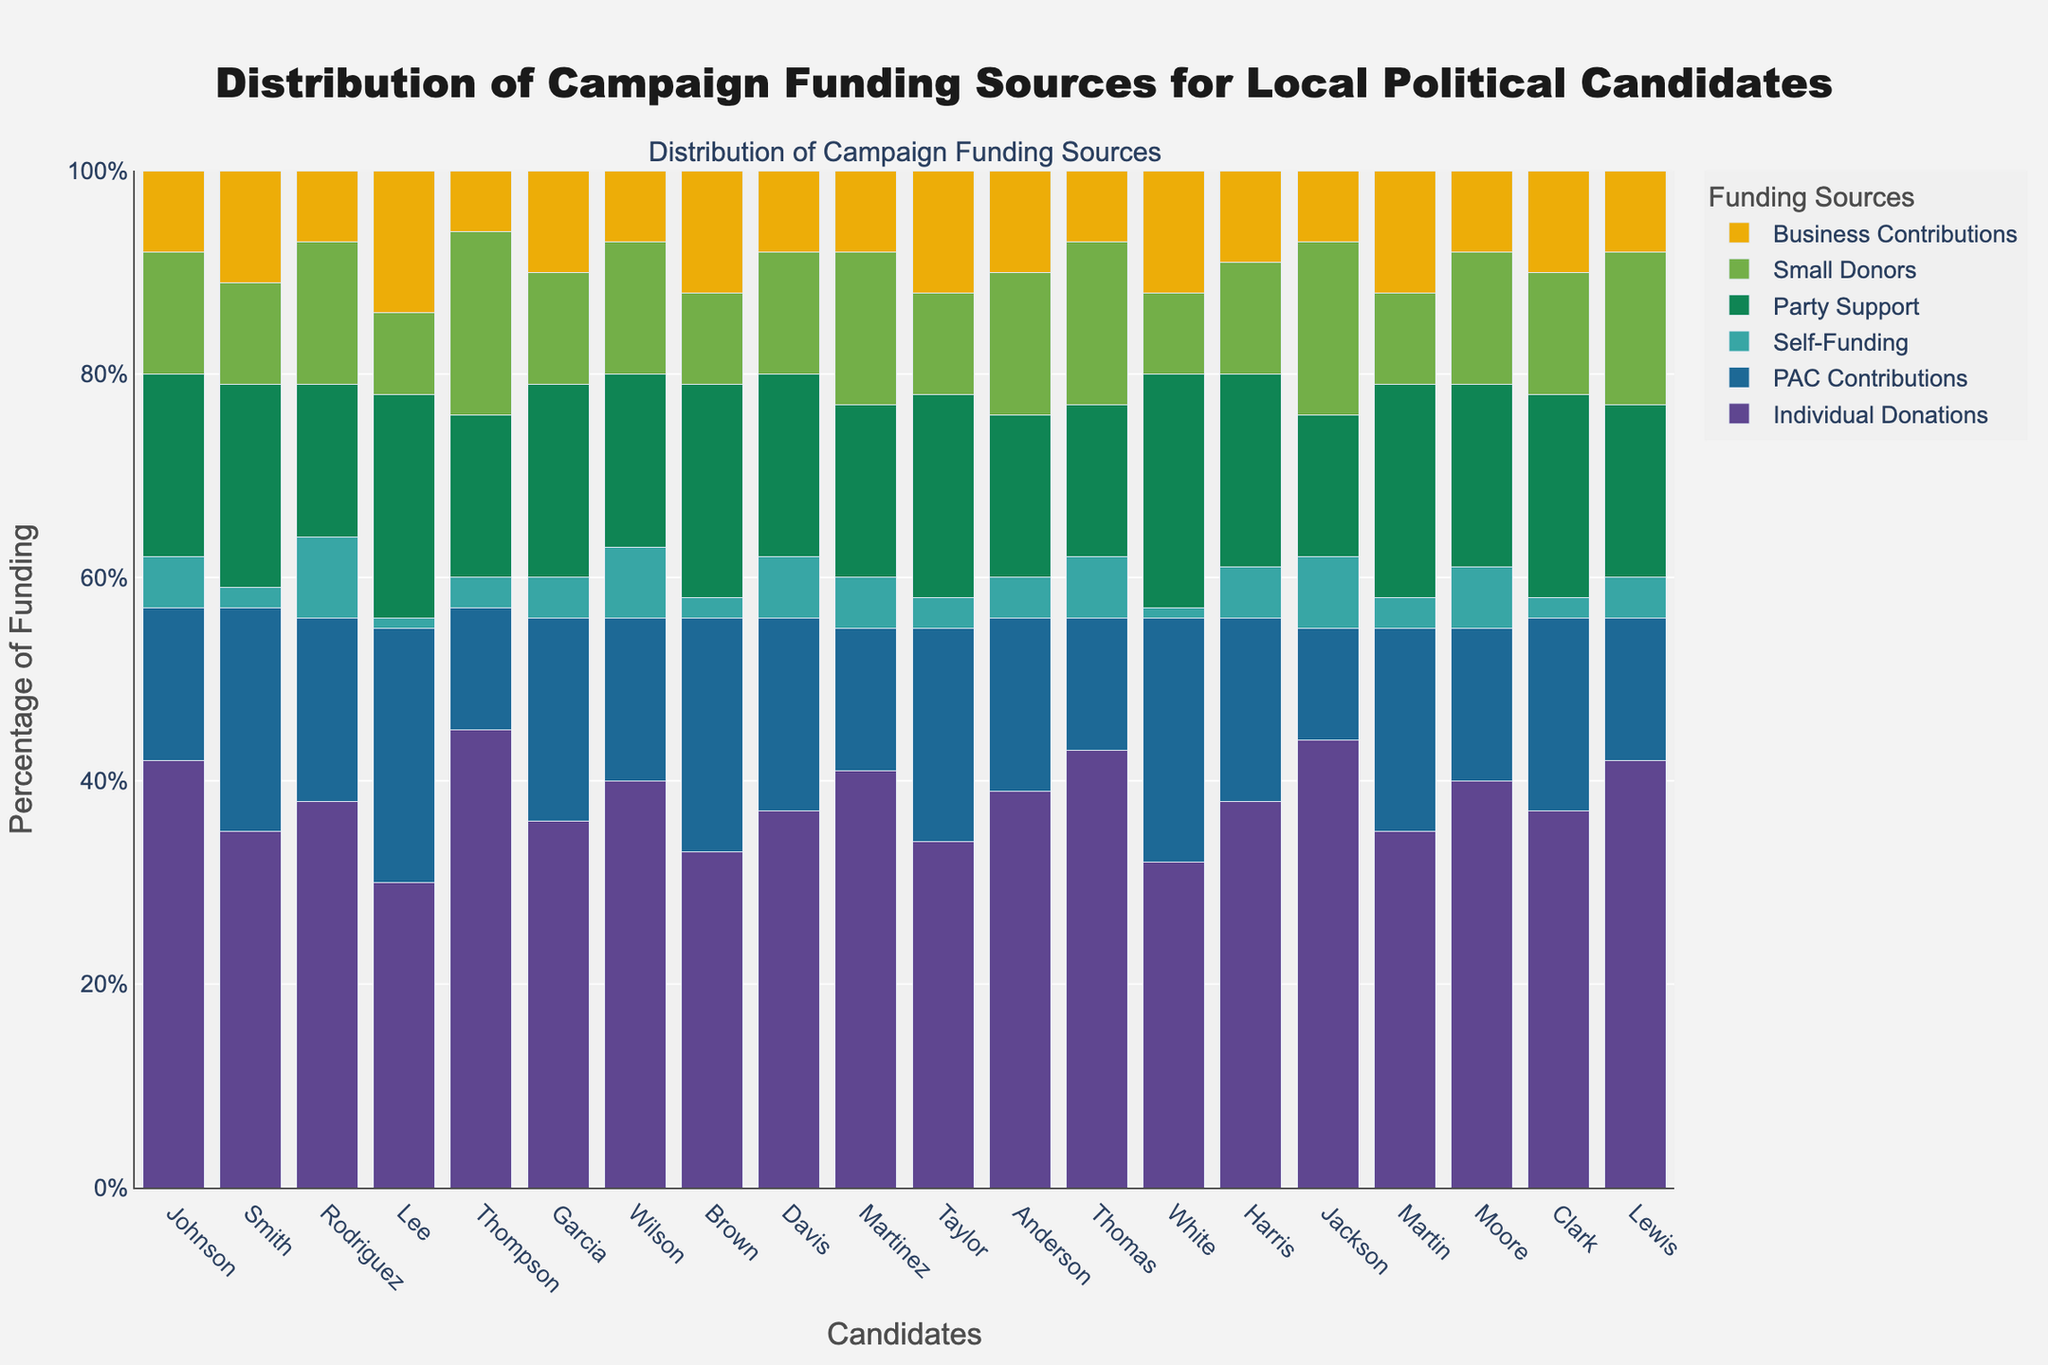What candidate has the highest percentage of PAC Contributions? From the figure, it can be observed that the bar for PAC Contributions is highest for the candidate with the name beneath it where this source contributes the most.
Answer: Lee How many candidates have more than 40% of their funding from Individual Donations? By visually inspecting the bars for Individual Donations, count the number of candidates with bars that extend above the 40% mark.
Answer: 10 Which funding source provides the least amount of support for the majority of the candidates? Observe all the bars for each funding source and identify the source with the shortest bars across the majority of candidates.
Answer: Self-Funding Compare Garcia and Lee’s contributions from Business Contributions. Who received more and by how much? Look at the heights of the bars for Business Contributions for Garcia and Lee, respectively, and calculate the difference.
Answer: Lee by 4% What is the total funding percentage from Small Donors for Rodriguez and Taylor combined? Sum up the percentages of Small Donors corresponding to Rodriguez and Taylor. Rodriguez has 14% and Taylor has 10%. So, 14% + 10% = 24%
Answer: 24% Who has the largest combined percentage from Individual Donations and Party Support? Sum the Individual Donations and Party Support percentages of each candidate. The candidate with the highest combined sum is the answer.
Answer: Johnson How does the Party Support percentage for White compare to Small Donors percentage for Thompson? Verify the heights of the bars representing Party Support for White and Small Donors for Thompson. Then, check if they are equal or which one is greater and by how much.
Answer: White's Party Support is 23% while Thompson's Small Donors is 18%; White's is greater by 5% Which funding source shows the largest variance among all candidates? Observe the spread or variability of the heights of the bars for each funding source. The one with the most variation (from lowest to highest) indicates the largest variance.
Answer: Party Support How many candidates have their highest percentage of funding from Self-Funding? Identify the tallest bar for each candidate and check which candidates have this highest bar in the Self-Funding category.
Answer: 0 